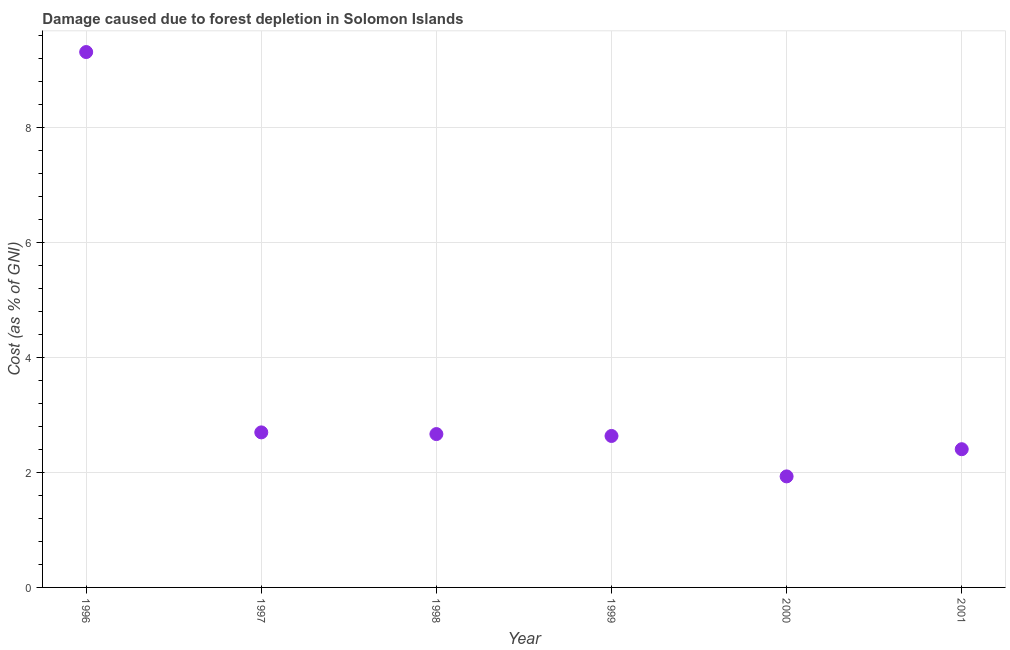What is the damage caused due to forest depletion in 1999?
Provide a succinct answer. 2.64. Across all years, what is the maximum damage caused due to forest depletion?
Your answer should be compact. 9.32. Across all years, what is the minimum damage caused due to forest depletion?
Keep it short and to the point. 1.93. In which year was the damage caused due to forest depletion minimum?
Make the answer very short. 2000. What is the sum of the damage caused due to forest depletion?
Offer a very short reply. 21.66. What is the difference between the damage caused due to forest depletion in 1996 and 1997?
Provide a short and direct response. 6.62. What is the average damage caused due to forest depletion per year?
Your response must be concise. 3.61. What is the median damage caused due to forest depletion?
Keep it short and to the point. 2.65. In how many years, is the damage caused due to forest depletion greater than 1.6 %?
Keep it short and to the point. 6. Do a majority of the years between 2000 and 1999 (inclusive) have damage caused due to forest depletion greater than 3.2 %?
Your response must be concise. No. What is the ratio of the damage caused due to forest depletion in 1999 to that in 2001?
Offer a terse response. 1.1. Is the difference between the damage caused due to forest depletion in 1998 and 1999 greater than the difference between any two years?
Your answer should be compact. No. What is the difference between the highest and the second highest damage caused due to forest depletion?
Provide a succinct answer. 6.62. Is the sum of the damage caused due to forest depletion in 1997 and 2000 greater than the maximum damage caused due to forest depletion across all years?
Provide a short and direct response. No. What is the difference between the highest and the lowest damage caused due to forest depletion?
Provide a short and direct response. 7.39. In how many years, is the damage caused due to forest depletion greater than the average damage caused due to forest depletion taken over all years?
Keep it short and to the point. 1. Does the damage caused due to forest depletion monotonically increase over the years?
Your answer should be very brief. No. How many years are there in the graph?
Keep it short and to the point. 6. Does the graph contain any zero values?
Provide a succinct answer. No. What is the title of the graph?
Give a very brief answer. Damage caused due to forest depletion in Solomon Islands. What is the label or title of the X-axis?
Keep it short and to the point. Year. What is the label or title of the Y-axis?
Ensure brevity in your answer.  Cost (as % of GNI). What is the Cost (as % of GNI) in 1996?
Your answer should be compact. 9.32. What is the Cost (as % of GNI) in 1997?
Provide a succinct answer. 2.7. What is the Cost (as % of GNI) in 1998?
Offer a very short reply. 2.67. What is the Cost (as % of GNI) in 1999?
Your response must be concise. 2.64. What is the Cost (as % of GNI) in 2000?
Your answer should be very brief. 1.93. What is the Cost (as % of GNI) in 2001?
Make the answer very short. 2.41. What is the difference between the Cost (as % of GNI) in 1996 and 1997?
Offer a very short reply. 6.62. What is the difference between the Cost (as % of GNI) in 1996 and 1998?
Give a very brief answer. 6.65. What is the difference between the Cost (as % of GNI) in 1996 and 1999?
Provide a succinct answer. 6.68. What is the difference between the Cost (as % of GNI) in 1996 and 2000?
Provide a short and direct response. 7.39. What is the difference between the Cost (as % of GNI) in 1996 and 2001?
Provide a succinct answer. 6.91. What is the difference between the Cost (as % of GNI) in 1997 and 1998?
Ensure brevity in your answer.  0.03. What is the difference between the Cost (as % of GNI) in 1997 and 1999?
Offer a very short reply. 0.06. What is the difference between the Cost (as % of GNI) in 1997 and 2000?
Ensure brevity in your answer.  0.77. What is the difference between the Cost (as % of GNI) in 1997 and 2001?
Make the answer very short. 0.29. What is the difference between the Cost (as % of GNI) in 1998 and 1999?
Keep it short and to the point. 0.03. What is the difference between the Cost (as % of GNI) in 1998 and 2000?
Keep it short and to the point. 0.74. What is the difference between the Cost (as % of GNI) in 1998 and 2001?
Offer a terse response. 0.26. What is the difference between the Cost (as % of GNI) in 1999 and 2000?
Make the answer very short. 0.7. What is the difference between the Cost (as % of GNI) in 1999 and 2001?
Offer a very short reply. 0.23. What is the difference between the Cost (as % of GNI) in 2000 and 2001?
Provide a succinct answer. -0.47. What is the ratio of the Cost (as % of GNI) in 1996 to that in 1997?
Provide a short and direct response. 3.45. What is the ratio of the Cost (as % of GNI) in 1996 to that in 1998?
Your response must be concise. 3.49. What is the ratio of the Cost (as % of GNI) in 1996 to that in 1999?
Provide a succinct answer. 3.54. What is the ratio of the Cost (as % of GNI) in 1996 to that in 2000?
Offer a very short reply. 4.82. What is the ratio of the Cost (as % of GNI) in 1996 to that in 2001?
Offer a very short reply. 3.87. What is the ratio of the Cost (as % of GNI) in 1997 to that in 1999?
Make the answer very short. 1.02. What is the ratio of the Cost (as % of GNI) in 1997 to that in 2000?
Provide a succinct answer. 1.4. What is the ratio of the Cost (as % of GNI) in 1997 to that in 2001?
Offer a very short reply. 1.12. What is the ratio of the Cost (as % of GNI) in 1998 to that in 1999?
Provide a succinct answer. 1.01. What is the ratio of the Cost (as % of GNI) in 1998 to that in 2000?
Offer a terse response. 1.38. What is the ratio of the Cost (as % of GNI) in 1998 to that in 2001?
Offer a very short reply. 1.11. What is the ratio of the Cost (as % of GNI) in 1999 to that in 2000?
Offer a terse response. 1.36. What is the ratio of the Cost (as % of GNI) in 1999 to that in 2001?
Give a very brief answer. 1.1. What is the ratio of the Cost (as % of GNI) in 2000 to that in 2001?
Your answer should be very brief. 0.8. 